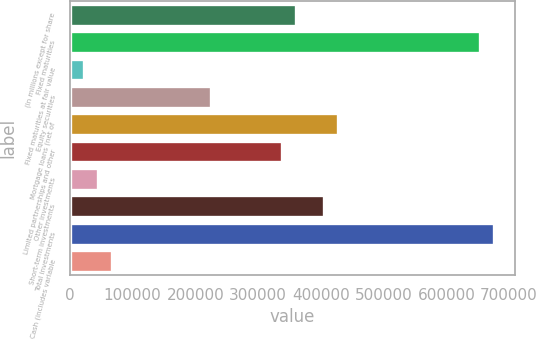<chart> <loc_0><loc_0><loc_500><loc_500><bar_chart><fcel>(In millions except for share<fcel>Fixed maturities<fcel>Fixed maturities at fair value<fcel>Equity securities<fcel>Mortgage loans (net of<fcel>Limited partnerships and other<fcel>Other investments<fcel>Short-term investments<fcel>Total investments<fcel>Cash (includes variable<nl><fcel>360414<fcel>653246<fcel>22529.6<fcel>225260<fcel>427990<fcel>337888<fcel>45055.2<fcel>405465<fcel>675772<fcel>67580.8<nl></chart> 